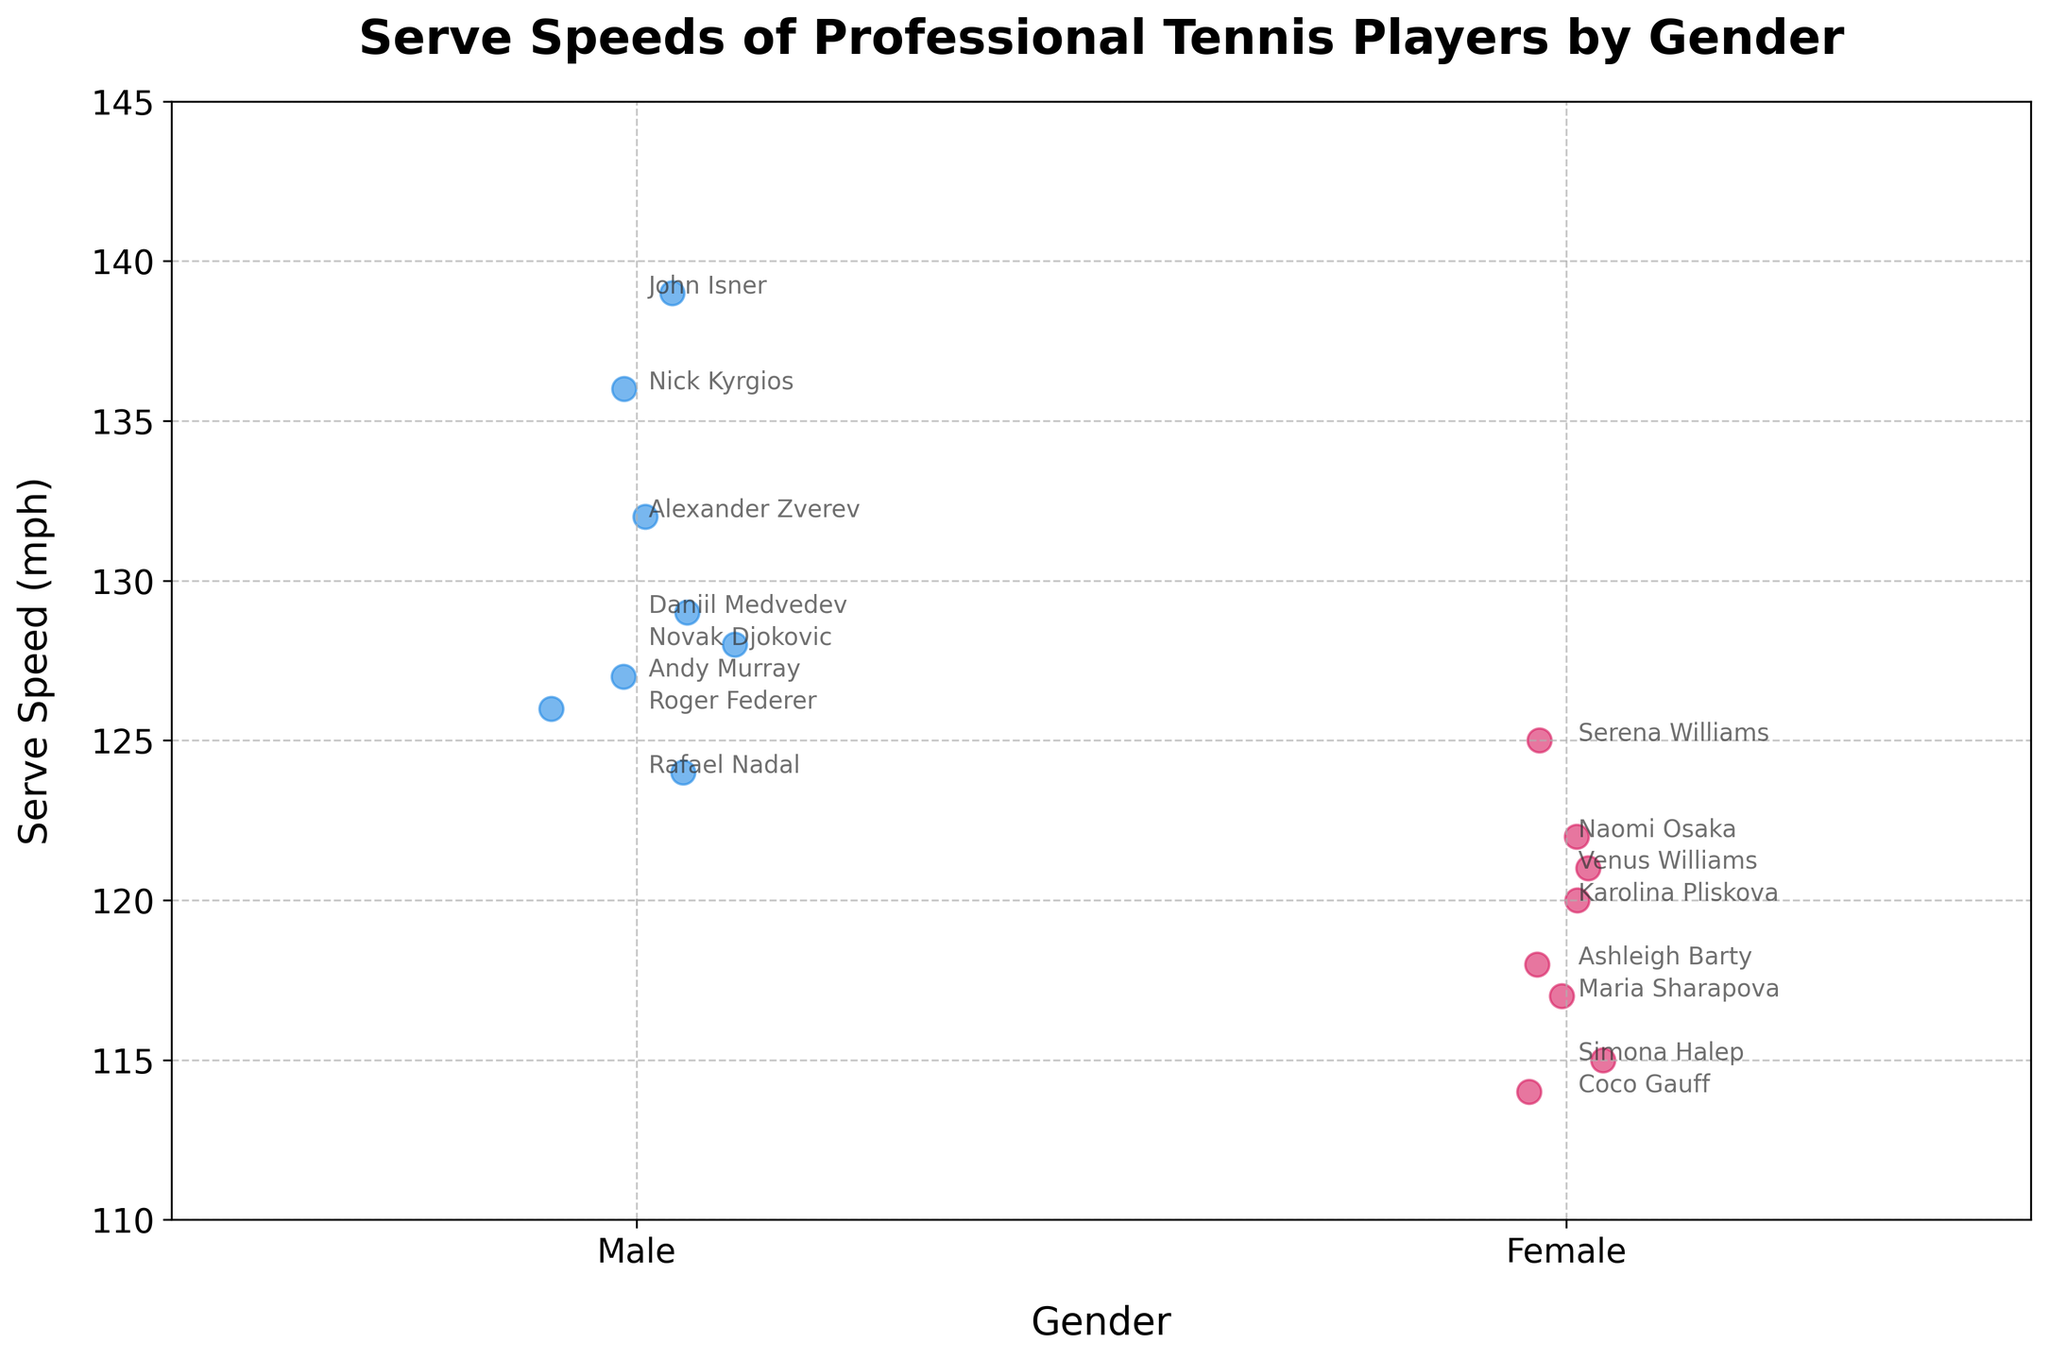What is the title of the strip plot? The title is usually located at the top of the figure and clearly states the main topic of the visualized data. In this case, the title is "Serve Speeds of Professional Tennis Players by Gender".
Answer: Serve Speeds of Professional Tennis Players by Gender Which axis represents the serve speed? To determine which axis represents serve speed, you must look at the labels of the axes. The y-axis is labeled "Serve Speed (mph)", so the serve speed is represented on the y-axis.
Answer: y-axis How many players are represented for each gender? To find the number of players for each gender, count the number of individual points for each gender category on the x-axis. There are 8 points for Male and 8 points for Female, making it 8 players for each gender.
Answer: 8 players each What is the serve speed of the fastest male tennis player? Look at the highest point in the 'Male' category on the y-axis. John Isner has the highest serve speed among males at 139 mph.
Answer: 139 mph What is the serve speed of the slowest female tennis player? Look at the lowest point in the 'Female' category on the y-axis. Coco Gauff has the lowest serve speed among females at 114 mph.
Answer: 114 mph Which male tennis player has a serve speed of 132 mph? Identify the dot that corresponds to 132 mph on the y-axis and look for the annotation next to it. Alexander Zverev is the male player with a serve speed of 132 mph.
Answer: Alexander Zverev Is the average serve speed of male players greater than that of female players? Calculate the average serve speed for both genders by summing up their serve speeds and dividing by the number of players. Males: (128+124+126+132+129+139+136+127)/8 = 130.125 mph. Females: (125+122+118+115+121+117+114+120)/8 = 119 mph. The average serve speed of male players is higher.
Answer: Yes What is the difference between the fastest serve speed among males and females? Identify the fastest serve speeds for both genders and subtract them. Male fastest: 139 mph, Female fastest: 125 mph. The difference is 139 - 125 = 14 mph.
Answer: 14 mph Which gender has more variability in serve speeds? Compare the range of serve speeds for both genders. Males range from 124 to 139 mph, a difference of 15 mph. Females range from 114 to 125 mph, a difference of 11 mph. Therefore, male players exhibit more variability.
Answer: Male Are there any male and female players with similar serve speeds? Look for dots within close proximity on the y-axis across both gender categories. Serena Williams (125 mph) and Roger Federer (126 mph) have similar serve speeds.
Answer: Yes 